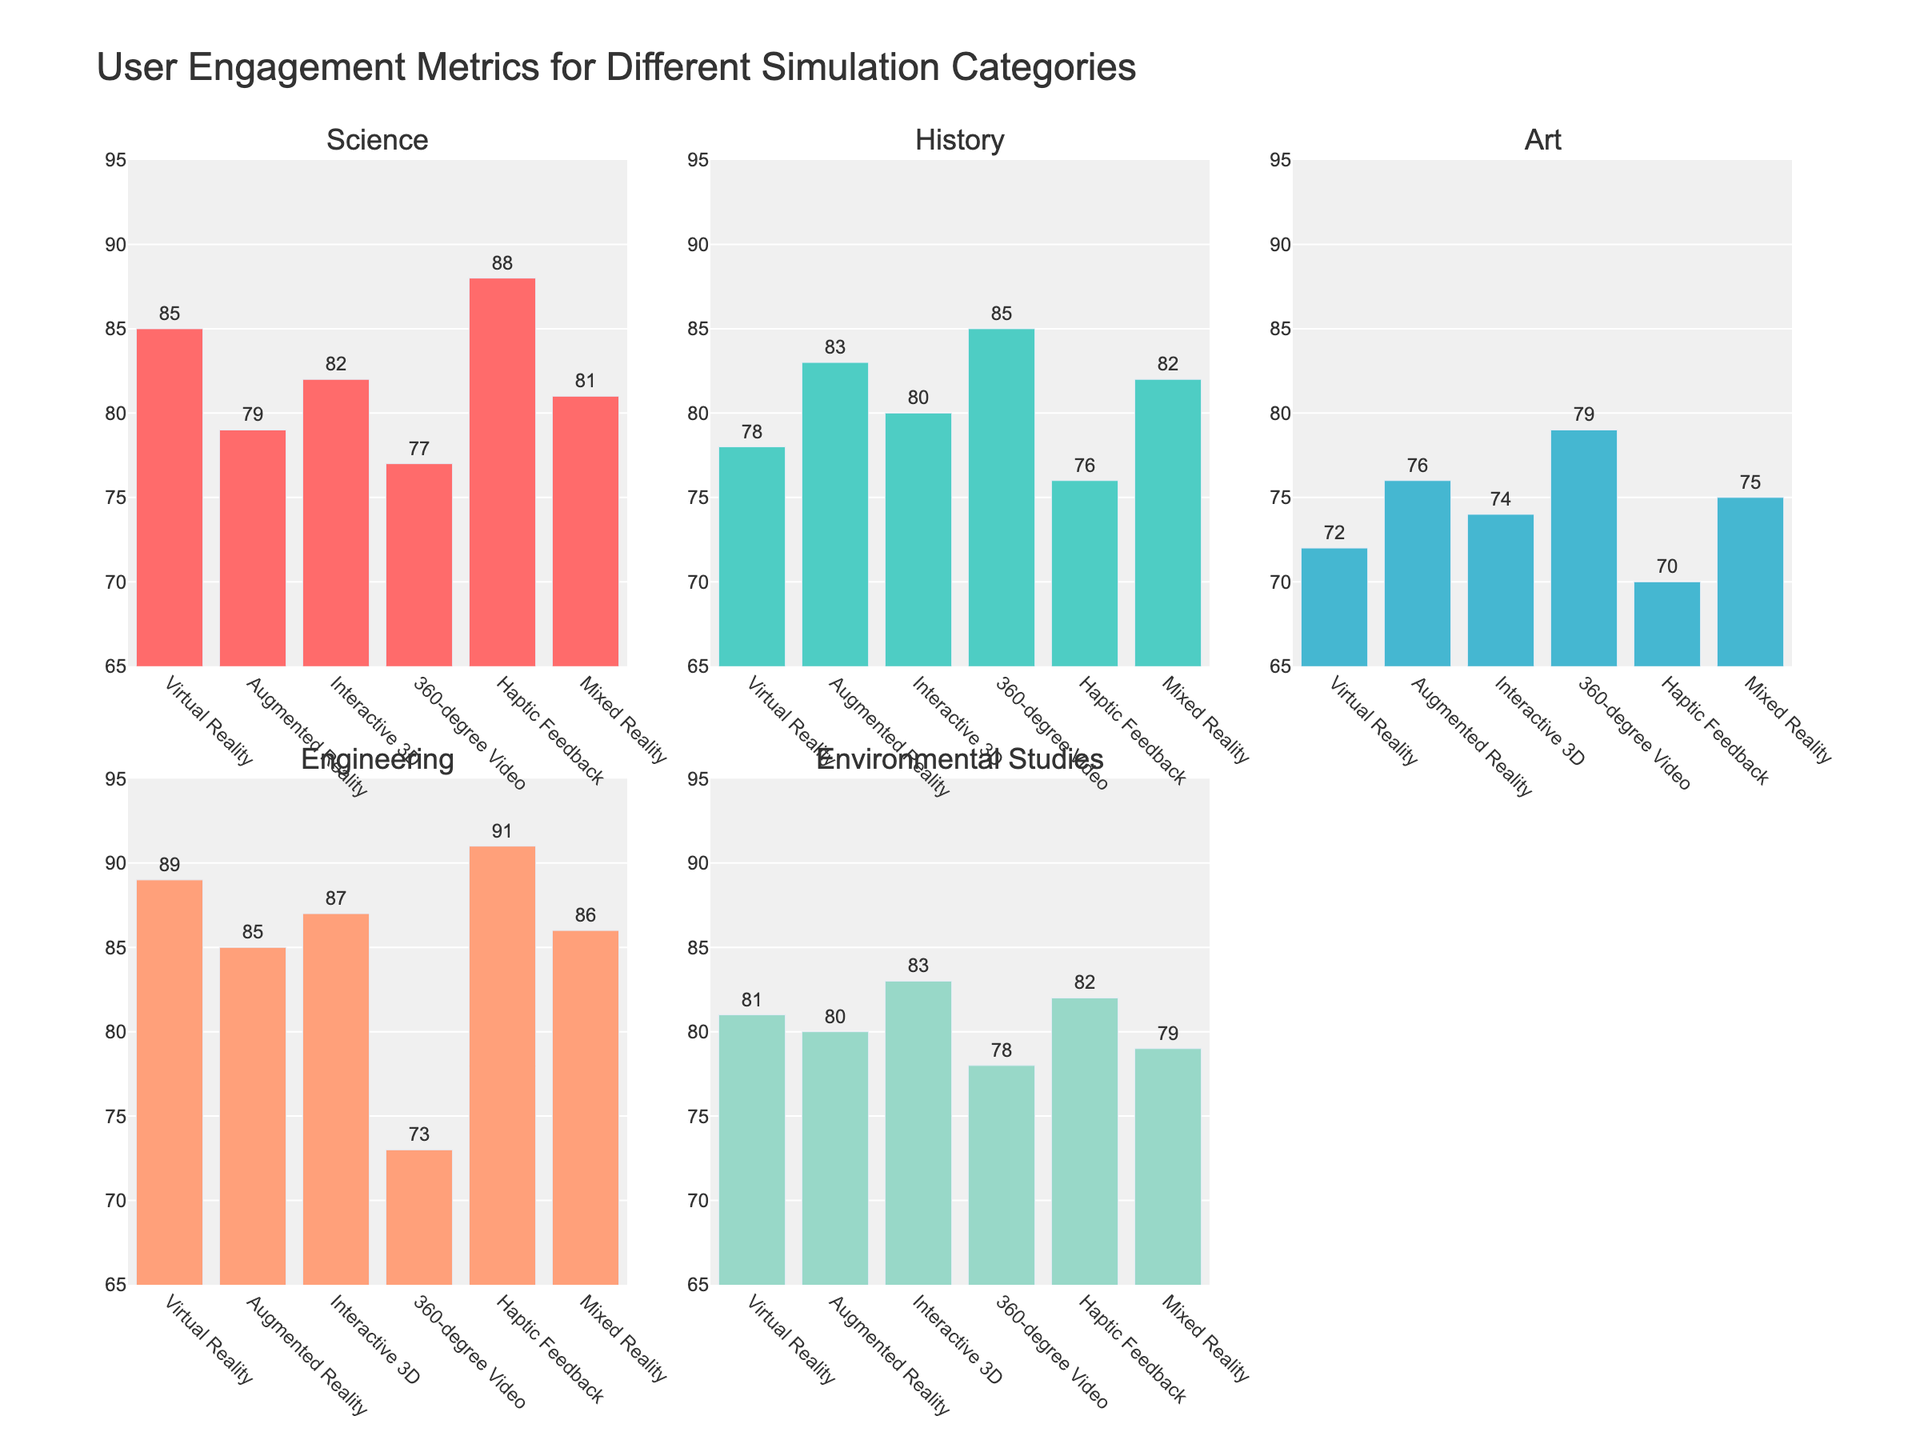Which simulation category has the highest engagement in Science? The bar corresponding to Science in the subplot shows the highest bar of all simulation categories. The Virtual Reality category shows the highest engagement with a value of 85.
Answer: Virtual Reality Which subject shows the maximum engagement for Haptic Feedback? In the Haptic Feedback bar group across all subplots, the tallest bar is for Engineering with a value of 91.
Answer: Engineering What is the average engagement value for Interactive 3D across all subjects? The engagement values for Interactive 3D across subjects are 82, 80, 74, 87, and 83. Calculating the average: (82 + 80 + 74 + 87 + 83) / 5 = 81.2.
Answer: 81.2 How does the engagement in History for 360-degree Video compare to Mixed Reality? In the History subplot, the height of the 360-degree Video bar is 85, while the Mixed Reality bar is 82. The engagement for 360-degree Video is higher by 3.
Answer: 360-degree Video is higher by 3 Which simulation category shows the least engagement in Art? In the subplot for Art, the shortest bar corresponds to Haptic Feedback with a value of 70.
Answer: Haptic Feedback Is Environmental Studies engagement for Augmented Reality higher or lower than for Virtual Reality? In the Environmental Studies subplot, the value for Augmented Reality is 80, while for Virtual Reality it is 81. The engagement for Augmented Reality is lower by 1.
Answer: Lower Among Science and History subjects, which simulation category has more consistent engagement values? Analyzing the bars in Science and History subplots, for Science the engagement ranges from 79 to 88, whereas in History from 76 to 85. The range is narrower in History, indicating more consistent values.
Answer: History What's the total engagement sum for Mixed Reality in all subjects? The engagement values for Mixed Reality across subjects are 81, 82, 75, 86, and 79. Summing these: 81 + 82 + 75 + 86 + 79 = 403.
Answer: 403 What is the difference in engagement between Engineering and Art for Augmented Reality? In the Augmented Reality subgroup, Engineering has an engagement of 85 and Art has 76. The difference is 85 - 76 = 9.
Answer: 9 How many simulation categories have their highest engagement value in the Environmental Studies subject? In the Environmental Studies subplot, the highest engagement value is 83 for Interactive 3D, 82 for Haptic Feedback, and 80 for Augmented Reality. Three categories have their highest values here.
Answer: 3 